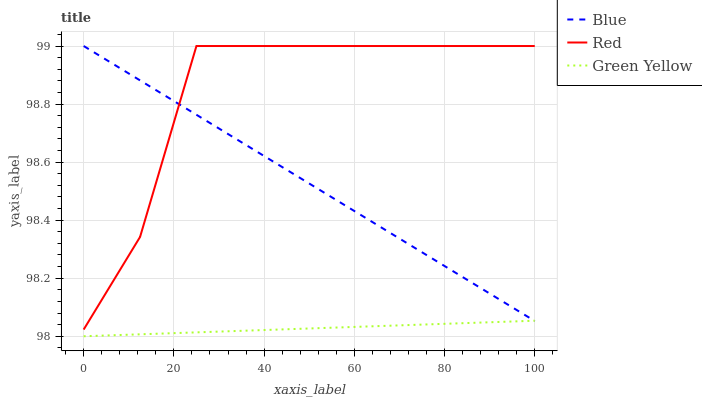Does Green Yellow have the minimum area under the curve?
Answer yes or no. Yes. Does Red have the maximum area under the curve?
Answer yes or no. Yes. Does Red have the minimum area under the curve?
Answer yes or no. No. Does Green Yellow have the maximum area under the curve?
Answer yes or no. No. Is Green Yellow the smoothest?
Answer yes or no. Yes. Is Red the roughest?
Answer yes or no. Yes. Is Red the smoothest?
Answer yes or no. No. Is Green Yellow the roughest?
Answer yes or no. No. Does Green Yellow have the lowest value?
Answer yes or no. Yes. Does Red have the lowest value?
Answer yes or no. No. Does Red have the highest value?
Answer yes or no. Yes. Does Green Yellow have the highest value?
Answer yes or no. No. Is Green Yellow less than Red?
Answer yes or no. Yes. Is Red greater than Green Yellow?
Answer yes or no. Yes. Does Blue intersect Red?
Answer yes or no. Yes. Is Blue less than Red?
Answer yes or no. No. Is Blue greater than Red?
Answer yes or no. No. Does Green Yellow intersect Red?
Answer yes or no. No. 